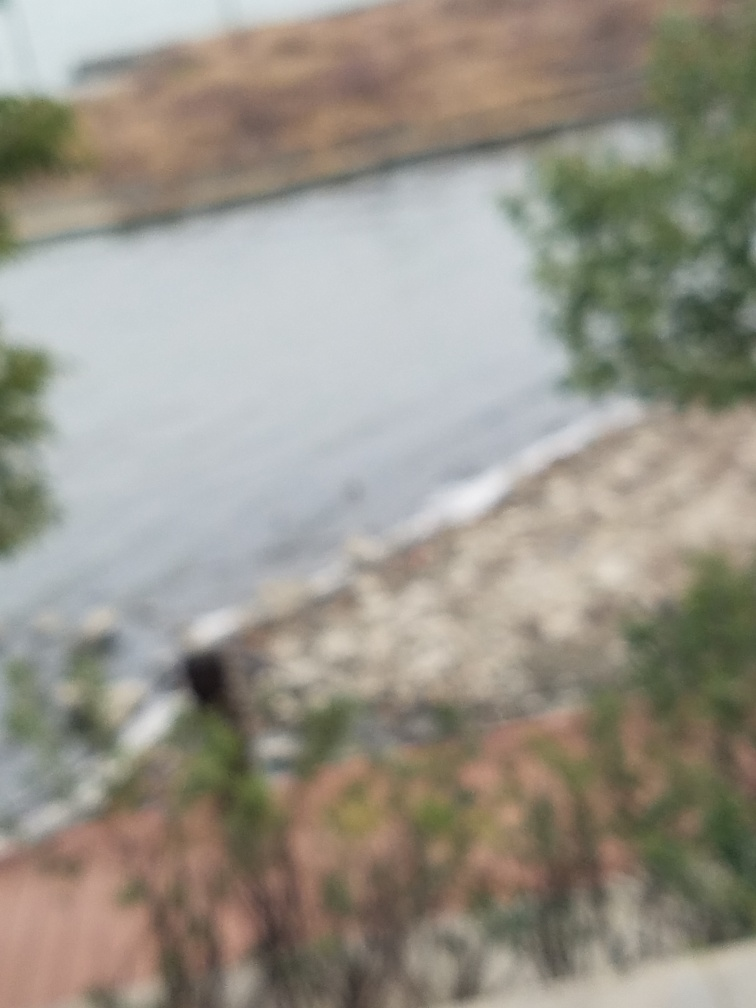Is there any way to tell what the weather might be like? While the specific weather conditions are not clear due to the image's lack of sharpness, the overall muted colors and lack of shadows could imply overcast or cloudy weather. 